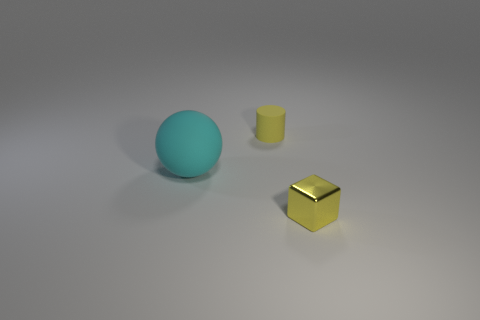The cylinder that is made of the same material as the large ball is what size?
Provide a short and direct response. Small. There is a thing that is the same color as the tiny cube; what is its size?
Keep it short and to the point. Small. Does the metallic thing have the same color as the small rubber thing?
Make the answer very short. Yes. Are there any small things of the same color as the cube?
Ensure brevity in your answer.  Yes. Do the rubber cylinder and the rubber thing in front of the small matte cylinder have the same size?
Your answer should be very brief. No. Do the shiny object and the yellow matte cylinder have the same size?
Provide a short and direct response. Yes. What number of other things are the same shape as the small rubber object?
Give a very brief answer. 0. There is a small yellow thing that is behind the tiny metal thing; what shape is it?
Keep it short and to the point. Cylinder. Are there an equal number of small objects that are right of the yellow matte object and large red metallic balls?
Provide a succinct answer. No. Is there anything else that has the same size as the cyan sphere?
Offer a very short reply. No. 